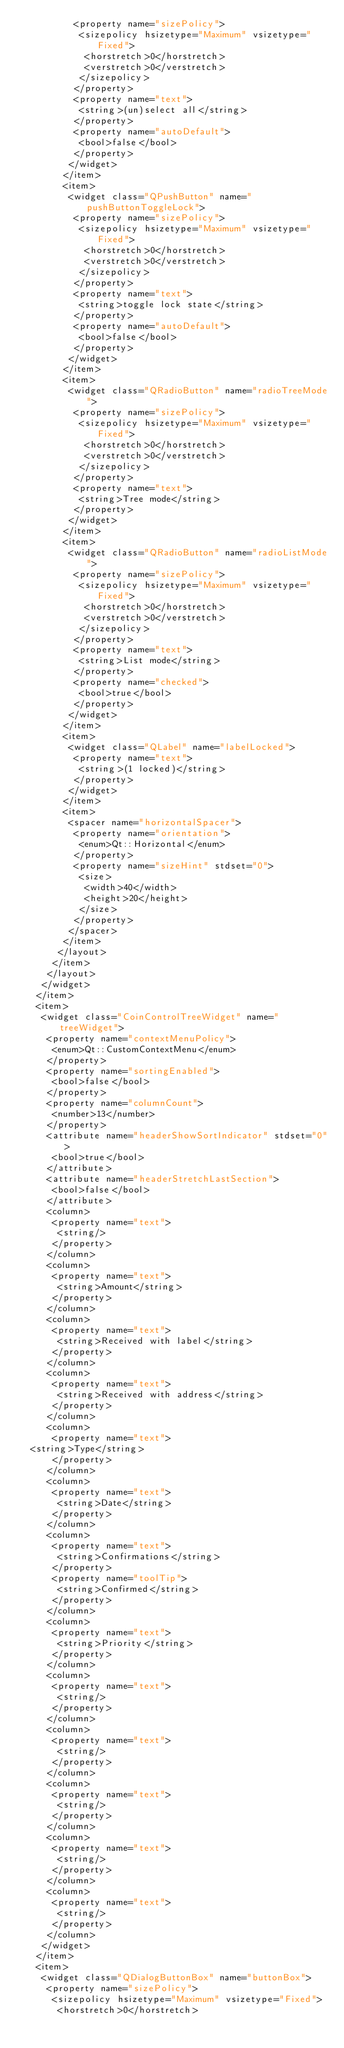<code> <loc_0><loc_0><loc_500><loc_500><_XML_>          <property name="sizePolicy">
           <sizepolicy hsizetype="Maximum" vsizetype="Fixed">
            <horstretch>0</horstretch>
            <verstretch>0</verstretch>
           </sizepolicy>
          </property>
          <property name="text">
           <string>(un)select all</string>
          </property>
          <property name="autoDefault">
           <bool>false</bool>
          </property>
         </widget>
        </item>
        <item>
         <widget class="QPushButton" name="pushButtonToggleLock">
          <property name="sizePolicy">
           <sizepolicy hsizetype="Maximum" vsizetype="Fixed">
            <horstretch>0</horstretch>
            <verstretch>0</verstretch>
           </sizepolicy>
          </property>
          <property name="text">
           <string>toggle lock state</string>
          </property>
          <property name="autoDefault">
           <bool>false</bool>
          </property>
         </widget>
        </item>
        <item>
         <widget class="QRadioButton" name="radioTreeMode">
          <property name="sizePolicy">
           <sizepolicy hsizetype="Maximum" vsizetype="Fixed">
            <horstretch>0</horstretch>
            <verstretch>0</verstretch>
           </sizepolicy>
          </property>
          <property name="text">
           <string>Tree mode</string>
          </property>
         </widget>
        </item>
        <item>
         <widget class="QRadioButton" name="radioListMode">
          <property name="sizePolicy">
           <sizepolicy hsizetype="Maximum" vsizetype="Fixed">
            <horstretch>0</horstretch>
            <verstretch>0</verstretch>
           </sizepolicy>
          </property>
          <property name="text">
           <string>List mode</string>
          </property>
          <property name="checked">
           <bool>true</bool>
          </property>
         </widget>
        </item>
        <item>
         <widget class="QLabel" name="labelLocked">
          <property name="text">
           <string>(1 locked)</string>
          </property>
         </widget>
        </item>
        <item>
         <spacer name="horizontalSpacer">
          <property name="orientation">
           <enum>Qt::Horizontal</enum>
          </property>
          <property name="sizeHint" stdset="0">
           <size>
            <width>40</width>
            <height>20</height>
           </size>
          </property>
         </spacer>
        </item>
       </layout>
      </item>
     </layout>
    </widget>
   </item>
   <item>
    <widget class="CoinControlTreeWidget" name="treeWidget">
     <property name="contextMenuPolicy">
      <enum>Qt::CustomContextMenu</enum>
     </property>
     <property name="sortingEnabled">
      <bool>false</bool>
     </property>
     <property name="columnCount">
      <number>13</number>
     </property>
     <attribute name="headerShowSortIndicator" stdset="0">
      <bool>true</bool>
     </attribute>
     <attribute name="headerStretchLastSection">
      <bool>false</bool>
     </attribute>
     <column>
      <property name="text">
       <string/>
      </property>
     </column>
     <column>
      <property name="text">
       <string>Amount</string>
      </property>
     </column>
     <column>
      <property name="text">
       <string>Received with label</string>
      </property>
     </column>
     <column>
      <property name="text">
       <string>Received with address</string>
      </property>
     </column>
     <column>
      <property name="text">
	<string>Type</string>
      </property>
     </column>
     <column>
      <property name="text">	 
       <string>Date</string>
      </property>
     </column>
     <column>
      <property name="text">
       <string>Confirmations</string>
      </property>
      <property name="toolTip">
       <string>Confirmed</string>
      </property>
     </column>
     <column>
      <property name="text">
       <string>Priority</string>
      </property>
     </column>
     <column>
      <property name="text">
       <string/>
      </property>
     </column>
     <column>
      <property name="text">
       <string/>
      </property>
     </column>
     <column>
      <property name="text">
       <string/>
      </property>
     </column>
     <column>
      <property name="text">
       <string/>
      </property>
     </column>
     <column>
      <property name="text">
       <string/>
      </property>
     </column>
    </widget>
   </item>
   <item>
    <widget class="QDialogButtonBox" name="buttonBox">
     <property name="sizePolicy">
      <sizepolicy hsizetype="Maximum" vsizetype="Fixed">
       <horstretch>0</horstretch></code> 